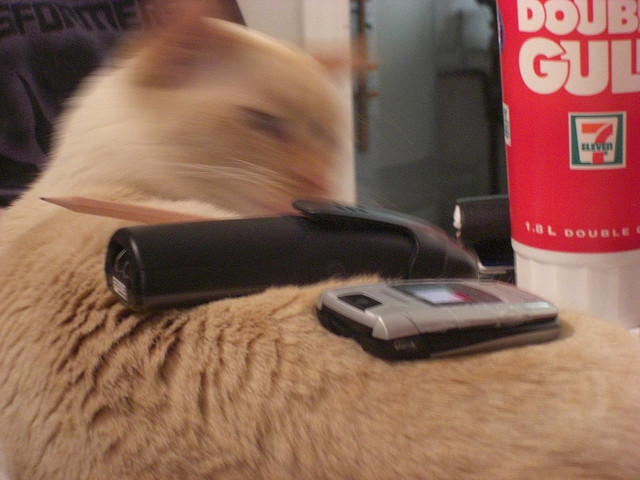Identify the text displayed in this image. DOUBLE DOUB GUL ELEVEN 1 L 